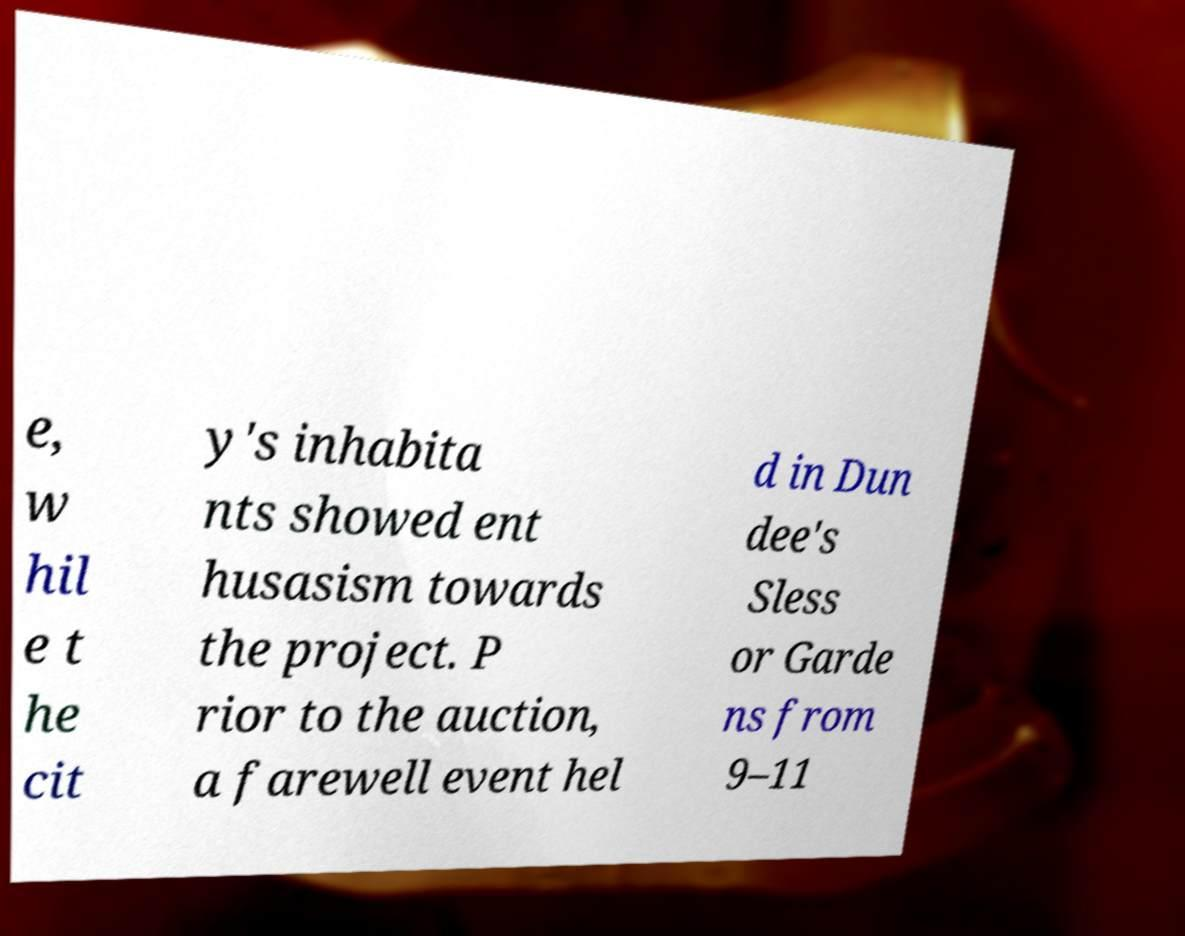Can you read and provide the text displayed in the image?This photo seems to have some interesting text. Can you extract and type it out for me? e, w hil e t he cit y's inhabita nts showed ent husasism towards the project. P rior to the auction, a farewell event hel d in Dun dee's Sless or Garde ns from 9–11 